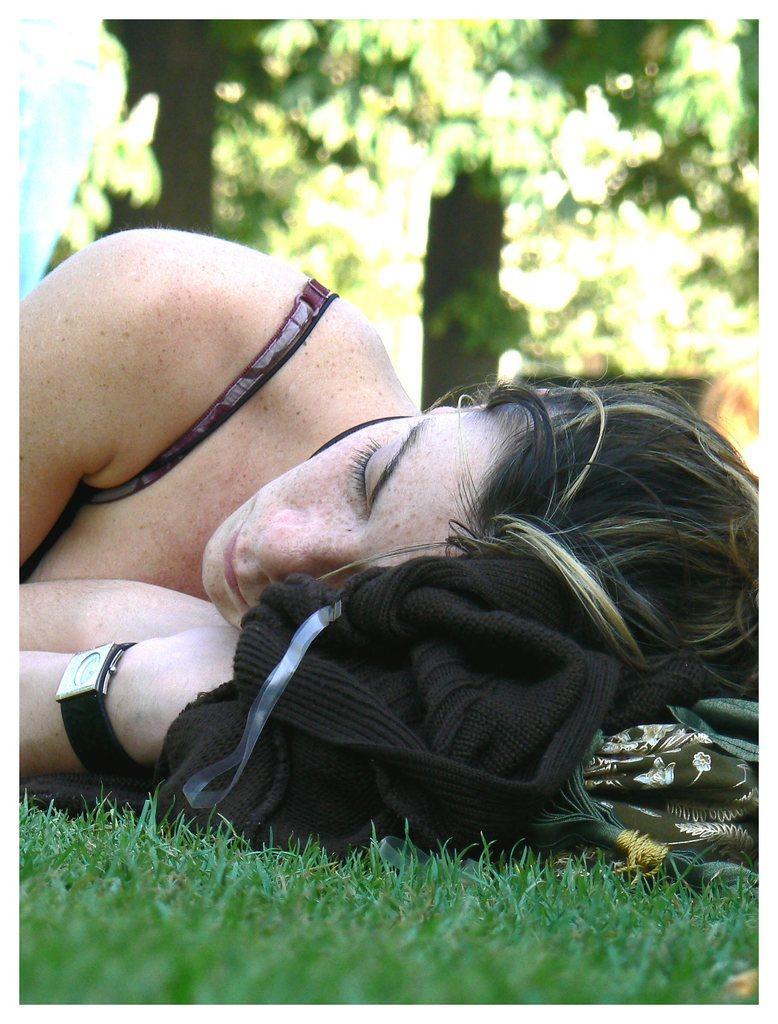Please provide a concise description of this image. At the bottom of the image there is grass, above the grass a woman is lying. Behind her there are some trees. 